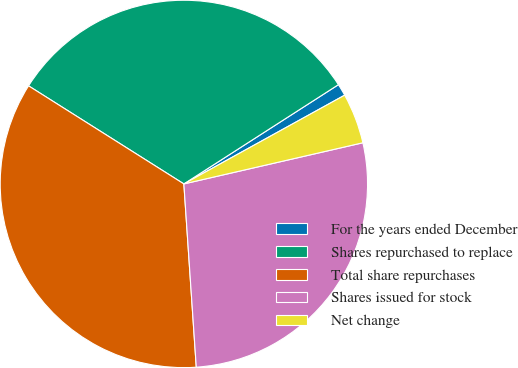Convert chart to OTSL. <chart><loc_0><loc_0><loc_500><loc_500><pie_chart><fcel>For the years ended December<fcel>Shares repurchased to replace<fcel>Total share repurchases<fcel>Shares issued for stock<fcel>Net change<nl><fcel>1.06%<fcel>31.95%<fcel>35.04%<fcel>27.52%<fcel>4.43%<nl></chart> 